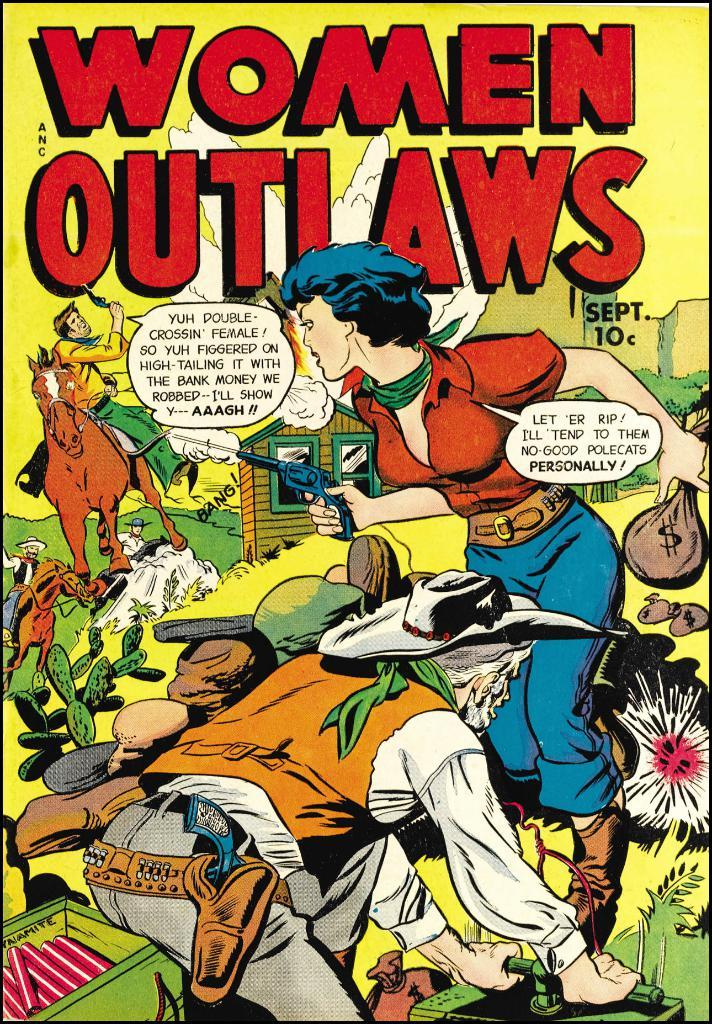<image>
Share a concise interpretation of the image provided. A copy of the comic Women Outlaws features a woman with a gun on the cover. 